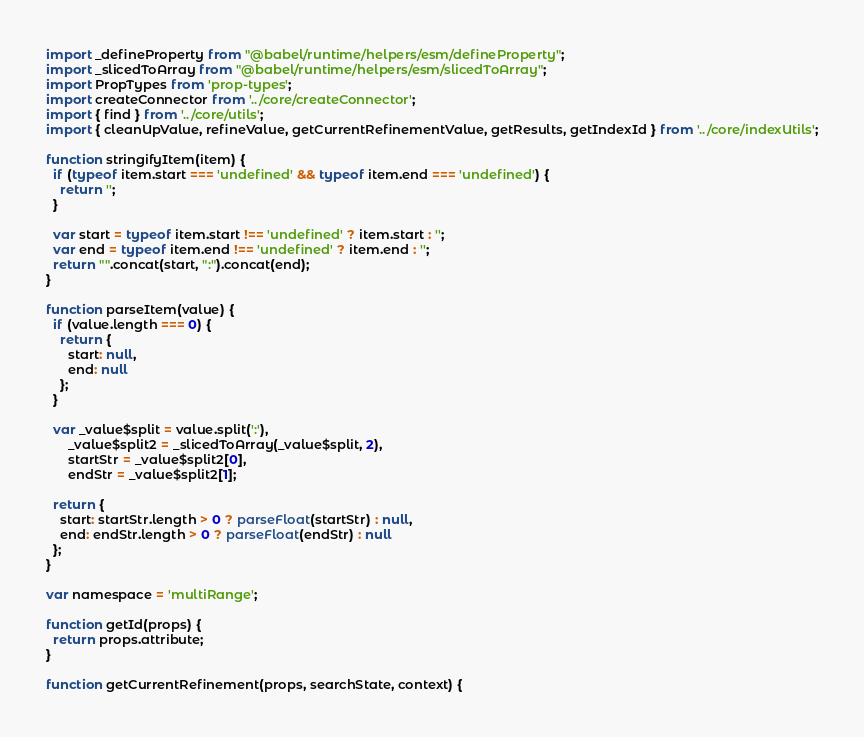Convert code to text. <code><loc_0><loc_0><loc_500><loc_500><_JavaScript_>import _defineProperty from "@babel/runtime/helpers/esm/defineProperty";
import _slicedToArray from "@babel/runtime/helpers/esm/slicedToArray";
import PropTypes from 'prop-types';
import createConnector from '../core/createConnector';
import { find } from '../core/utils';
import { cleanUpValue, refineValue, getCurrentRefinementValue, getResults, getIndexId } from '../core/indexUtils';

function stringifyItem(item) {
  if (typeof item.start === 'undefined' && typeof item.end === 'undefined') {
    return '';
  }

  var start = typeof item.start !== 'undefined' ? item.start : '';
  var end = typeof item.end !== 'undefined' ? item.end : '';
  return "".concat(start, ":").concat(end);
}

function parseItem(value) {
  if (value.length === 0) {
    return {
      start: null,
      end: null
    };
  }

  var _value$split = value.split(':'),
      _value$split2 = _slicedToArray(_value$split, 2),
      startStr = _value$split2[0],
      endStr = _value$split2[1];

  return {
    start: startStr.length > 0 ? parseFloat(startStr) : null,
    end: endStr.length > 0 ? parseFloat(endStr) : null
  };
}

var namespace = 'multiRange';

function getId(props) {
  return props.attribute;
}

function getCurrentRefinement(props, searchState, context) {</code> 